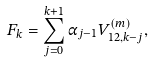<formula> <loc_0><loc_0><loc_500><loc_500>F _ { k } = \sum _ { j = 0 } ^ { k + 1 } \alpha _ { j - 1 } V _ { 1 2 , k - j } ^ { ( m ) } ,</formula> 